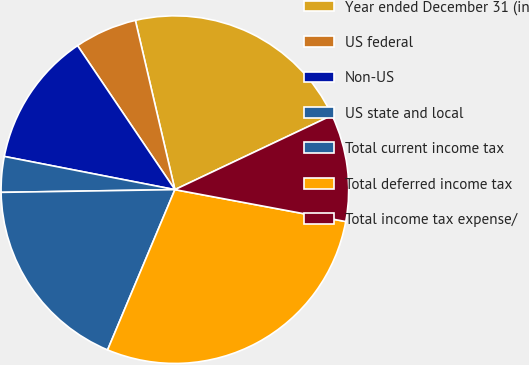Convert chart. <chart><loc_0><loc_0><loc_500><loc_500><pie_chart><fcel>Year ended December 31 (in<fcel>US federal<fcel>Non-US<fcel>US state and local<fcel>Total current income tax<fcel>Total deferred income tax<fcel>Total income tax expense/<nl><fcel>21.62%<fcel>5.81%<fcel>12.48%<fcel>3.31%<fcel>18.42%<fcel>28.39%<fcel>9.97%<nl></chart> 